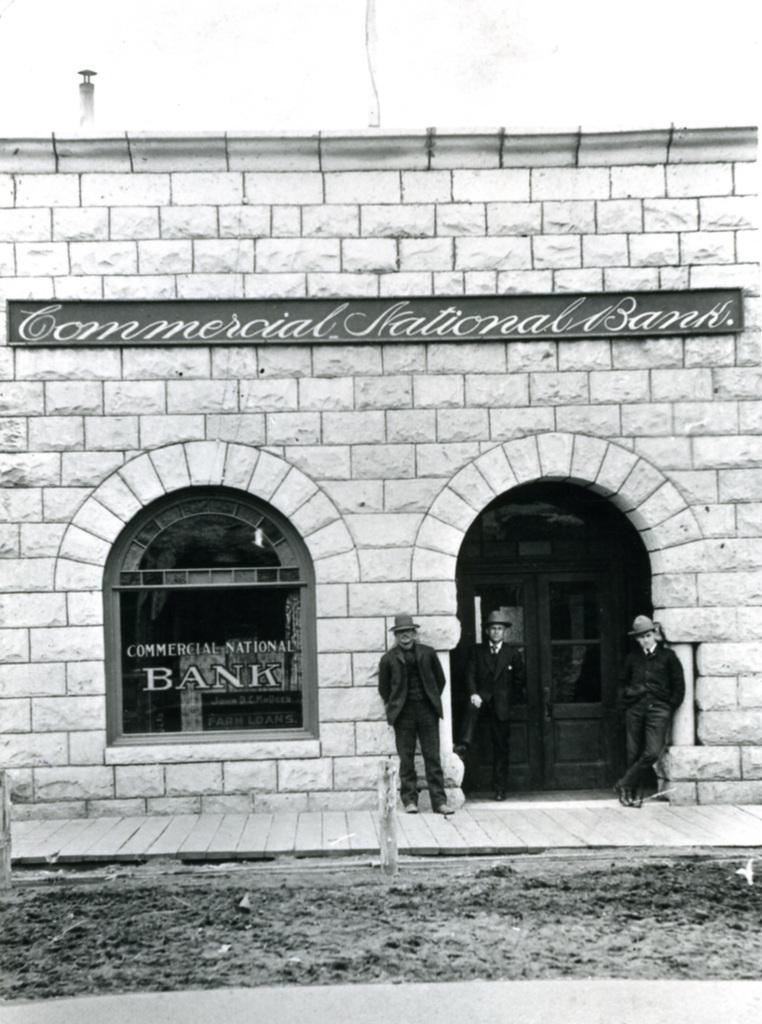What is the color scheme of the image? The image is in black and white. What can be seen within the image? There is a picture within the image. What is depicted in the picture within the image? The picture within the image shows the ground and a building. Are there any people visible in the picture within the image? Yes, there are people standing in the picture within the image. What is visible in the background of the picture within the image? The sky is visible in the background of the picture within the image. What type of yam is being harvested by the people in the image? There is no yam or harvesting activity depicted in the image. What color is the underwear worn by the people in the image? There is no underwear visible in the image, as the people are standing in a picture within the image, and their clothing is not discernible. 